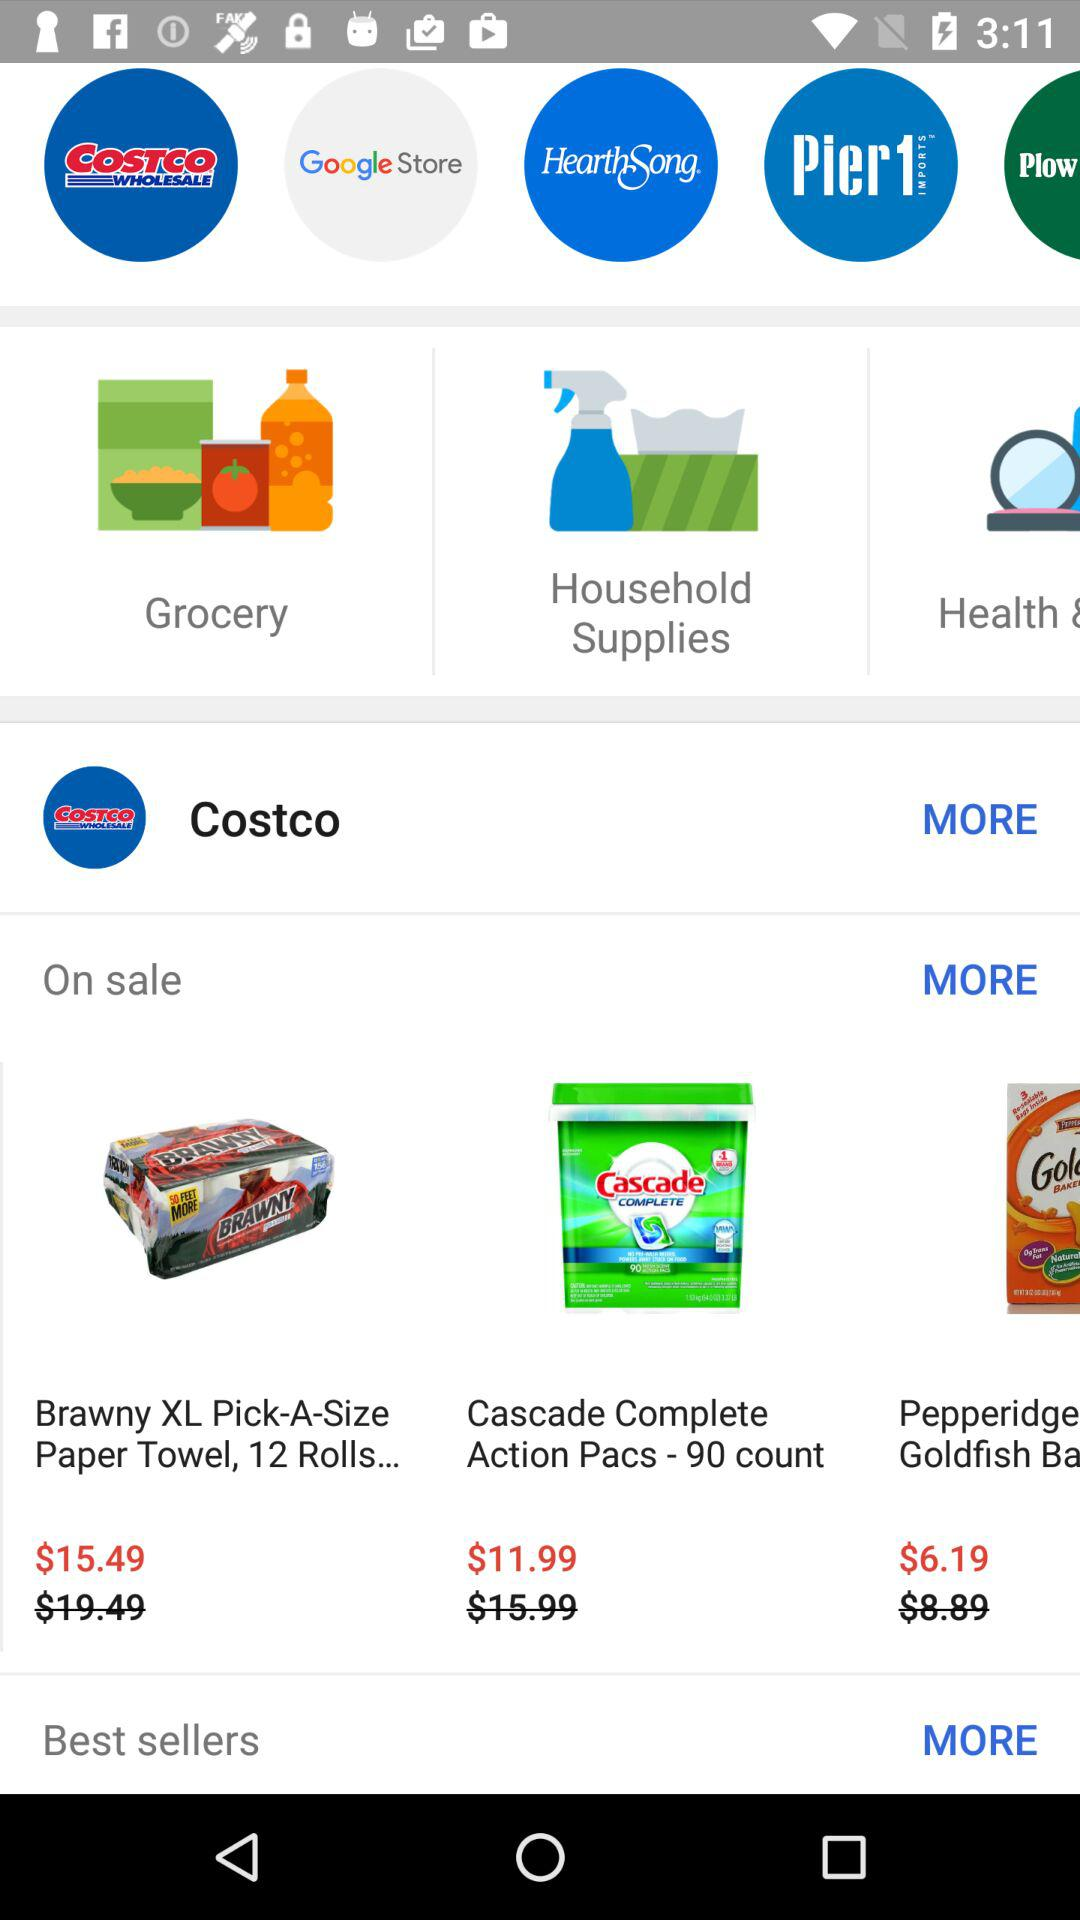What are the names of the few items that are on sale? The names of the few items are "Brawny XL Pick-A-Size Paper Towel, 12 Rolls..." and "Cascade Complete Action Pacs - 90 count". 